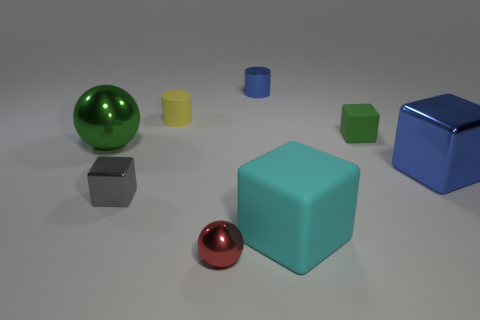Add 1 small red objects. How many objects exist? 9 Subtract all blue cubes. How many cubes are left? 3 Subtract all red balls. How many balls are left? 1 Subtract all yellow cylinders. How many green balls are left? 1 Subtract all small yellow cylinders. Subtract all rubber blocks. How many objects are left? 5 Add 1 cyan matte objects. How many cyan matte objects are left? 2 Add 6 gray blocks. How many gray blocks exist? 7 Subtract 0 cyan cylinders. How many objects are left? 8 Subtract all balls. How many objects are left? 6 Subtract 2 spheres. How many spheres are left? 0 